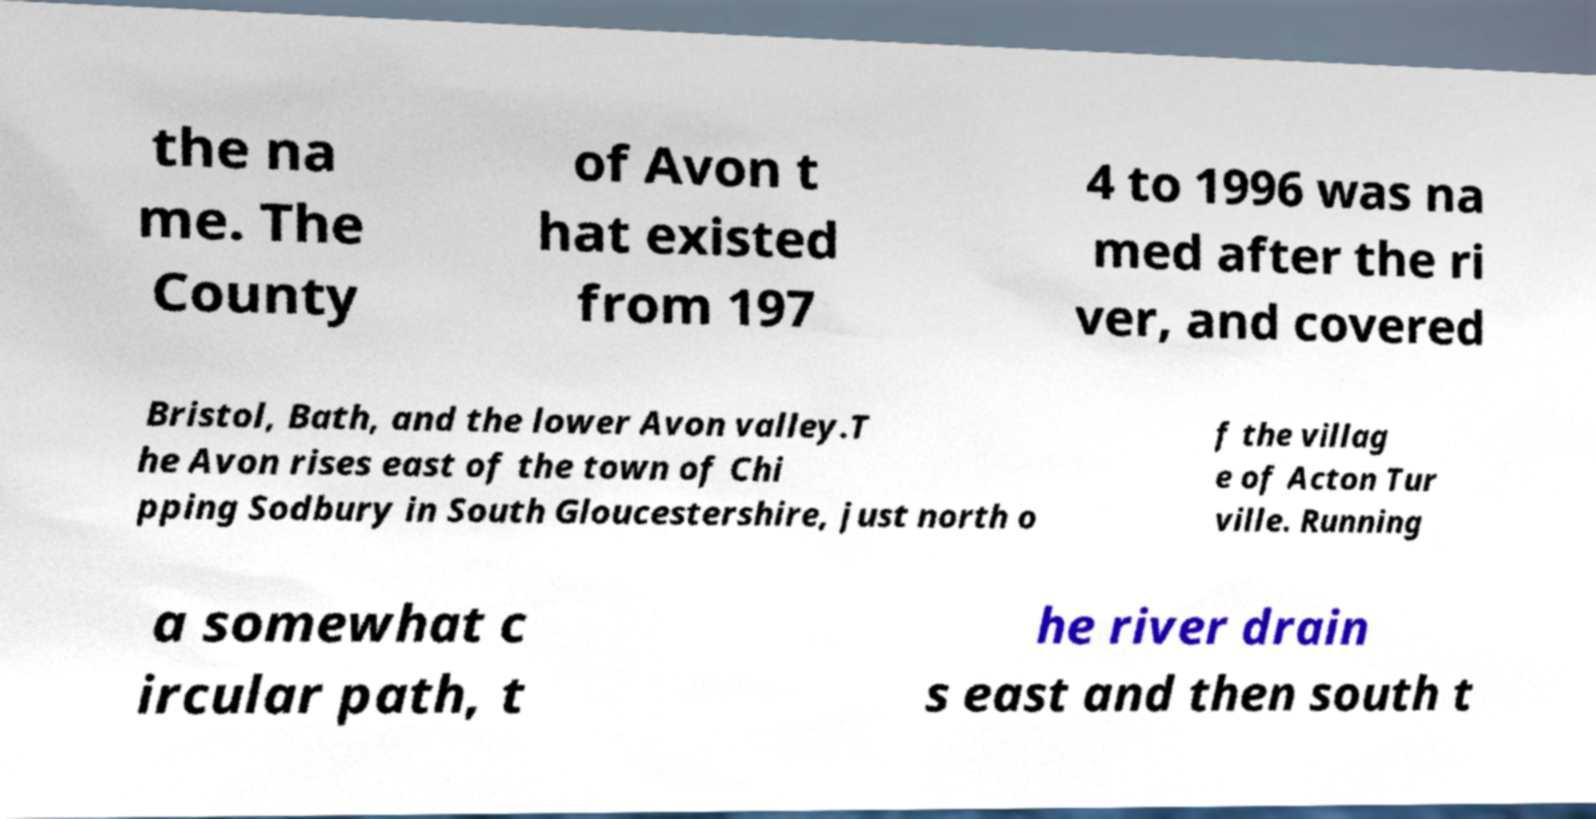There's text embedded in this image that I need extracted. Can you transcribe it verbatim? the na me. The County of Avon t hat existed from 197 4 to 1996 was na med after the ri ver, and covered Bristol, Bath, and the lower Avon valley.T he Avon rises east of the town of Chi pping Sodbury in South Gloucestershire, just north o f the villag e of Acton Tur ville. Running a somewhat c ircular path, t he river drain s east and then south t 